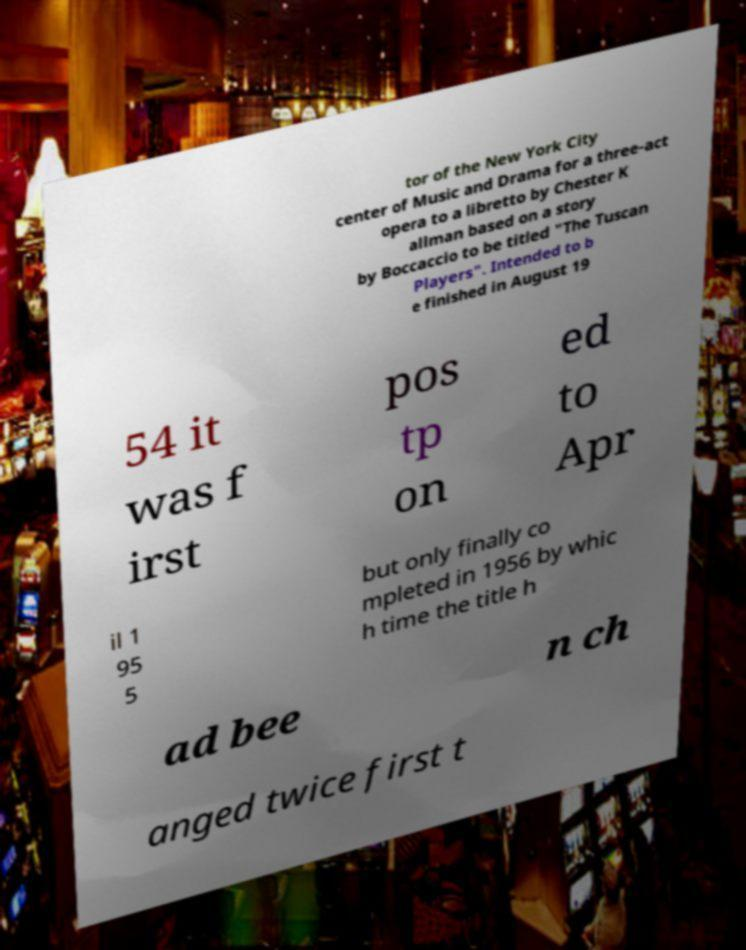I need the written content from this picture converted into text. Can you do that? tor of the New York City center of Music and Drama for a three-act opera to a libretto by Chester K allman based on a story by Boccaccio to be titled "The Tuscan Players". Intended to b e finished in August 19 54 it was f irst pos tp on ed to Apr il 1 95 5 but only finally co mpleted in 1956 by whic h time the title h ad bee n ch anged twice first t 